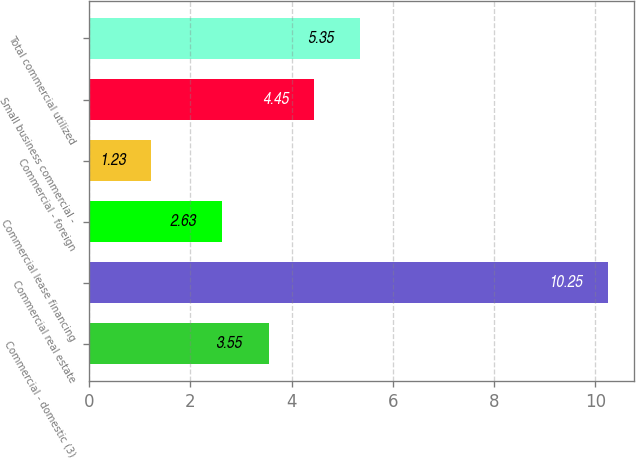<chart> <loc_0><loc_0><loc_500><loc_500><bar_chart><fcel>Commercial - domestic (3)<fcel>Commercial real estate<fcel>Commercial lease financing<fcel>Commercial - foreign<fcel>Small business commercial -<fcel>Total commercial utilized<nl><fcel>3.55<fcel>10.25<fcel>2.63<fcel>1.23<fcel>4.45<fcel>5.35<nl></chart> 